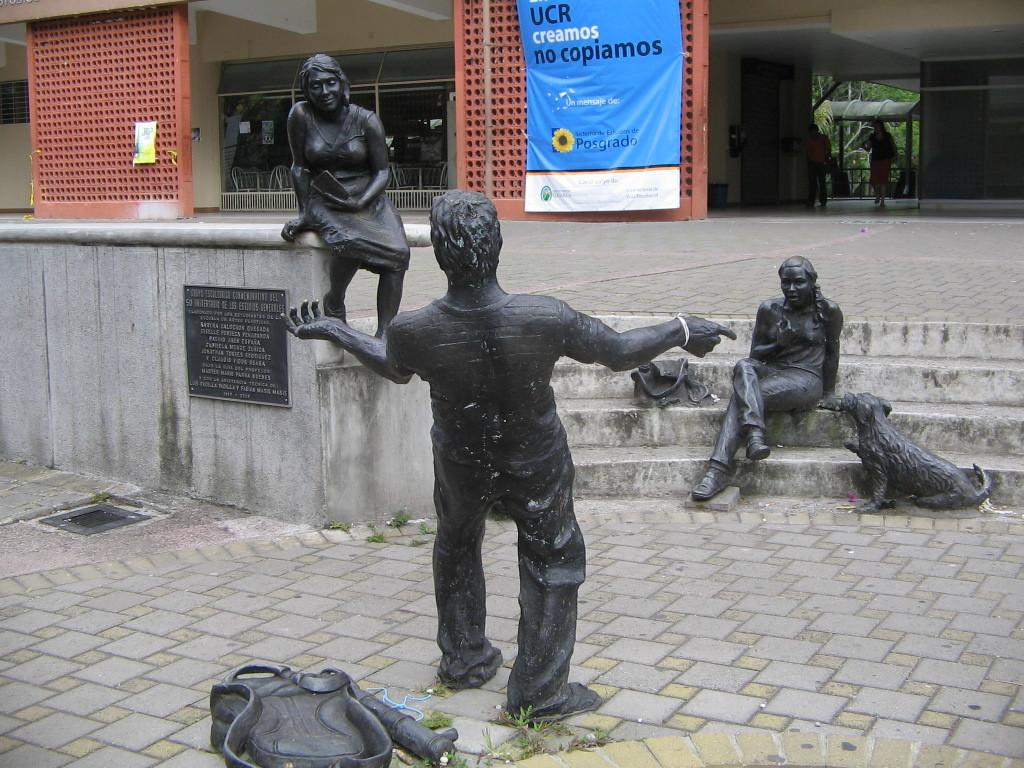What type of sculptures can be seen in the image? There are sculptures of two women and a man, as well as a sculpture of a dog in the image. What is located at the bottom of the image? There is a road at the bottom of the image. What can be seen in the background of the image? There are walls and banners in the background of the image. What type of drug is being sold on the road in the image? There is no indication of any drug being sold or present in the image. The image features sculptures and a road, but no reference to drugs or any related activity. 